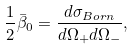<formula> <loc_0><loc_0><loc_500><loc_500>\frac { 1 } { 2 } \bar { \beta } _ { 0 } = \frac { d \sigma _ { B o r n } } { d \Omega _ { + } d \Omega _ { - } } ,</formula> 